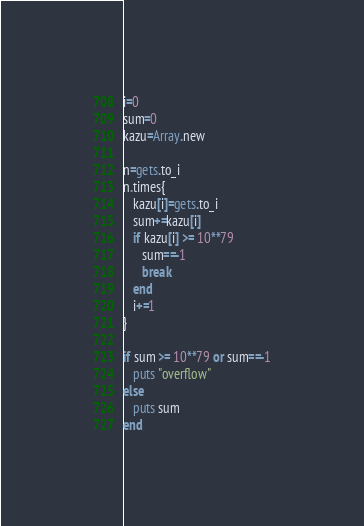Convert code to text. <code><loc_0><loc_0><loc_500><loc_500><_Ruby_>i=0
sum=0
kazu=Array.new

n=gets.to_i
n.times{
   kazu[i]=gets.to_i
   sum+=kazu[i]
   if kazu[i] >= 10**79
      sum==-1
      break
   end
   i+=1
}

if sum >= 10**79 or sum==-1
   puts "overflow"
else
   puts sum
end</code> 